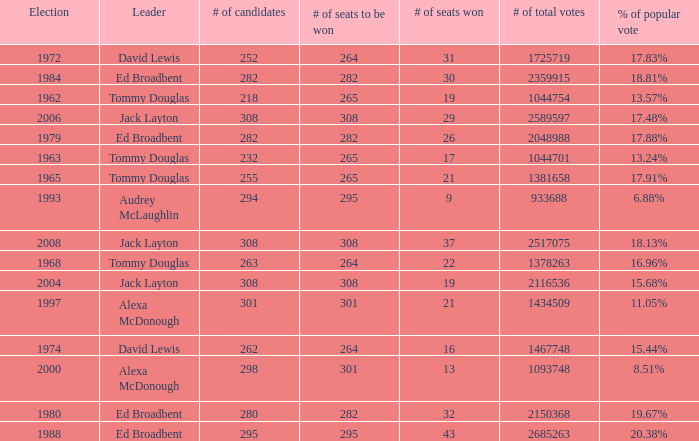Name the number of candidates for # of seats won being 43 295.0. 